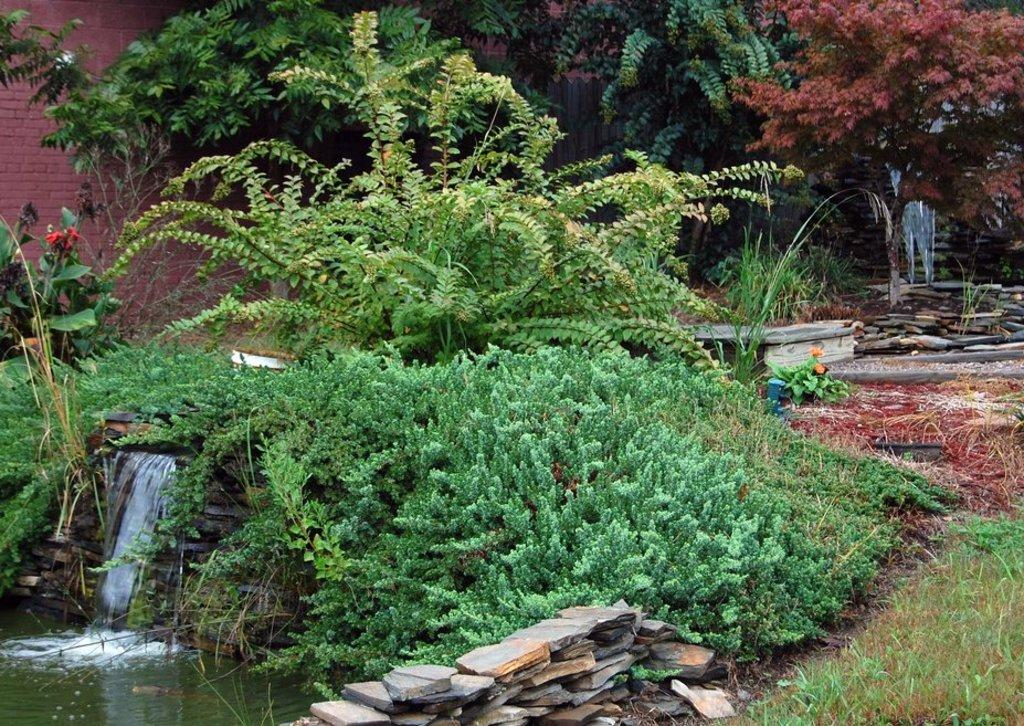What type of vegetation can be seen in the image? There are plants, trees, and grass visible in the image. What type of ground cover is present in the image? There are stones in the image. What natural element can be seen in the image? There is water visible in the image. What type of structure is present in the image? There is a brick wall in the image. Can you compare the size of the feather to the plants in the image? There is no feather present in the image, so it cannot be compared to the plants. Is it raining in the image? There is no indication of rain in the image; it only shows plants, trees, grass, stones, water, and a brick wall. 